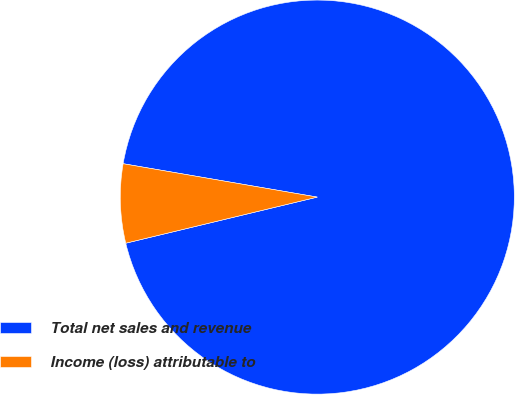<chart> <loc_0><loc_0><loc_500><loc_500><pie_chart><fcel>Total net sales and revenue<fcel>Income (loss) attributable to<nl><fcel>93.53%<fcel>6.47%<nl></chart> 